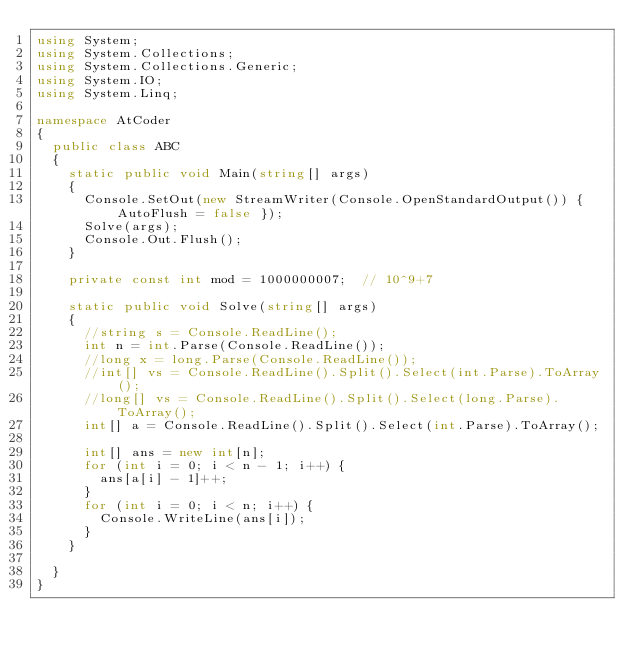Convert code to text. <code><loc_0><loc_0><loc_500><loc_500><_C#_>using System;
using System.Collections;
using System.Collections.Generic;
using System.IO;
using System.Linq;

namespace AtCoder
{
	public class ABC
	{
		static public void Main(string[] args)
		{
			Console.SetOut(new StreamWriter(Console.OpenStandardOutput()) { AutoFlush = false });
			Solve(args);
			Console.Out.Flush();
		}

		private const int mod = 1000000007;  // 10^9+7

		static public void Solve(string[] args)
		{
			//string s = Console.ReadLine();
			int n = int.Parse(Console.ReadLine());
			//long x = long.Parse(Console.ReadLine());
			//int[] vs = Console.ReadLine().Split().Select(int.Parse).ToArray();
			//long[] vs = Console.ReadLine().Split().Select(long.Parse).ToArray();
			int[] a = Console.ReadLine().Split().Select(int.Parse).ToArray();

			int[] ans = new int[n];
			for (int i = 0; i < n - 1; i++) {
				ans[a[i] - 1]++;
			}
			for (int i = 0; i < n; i++) {
				Console.WriteLine(ans[i]);
			}
		}

	}
}
</code> 